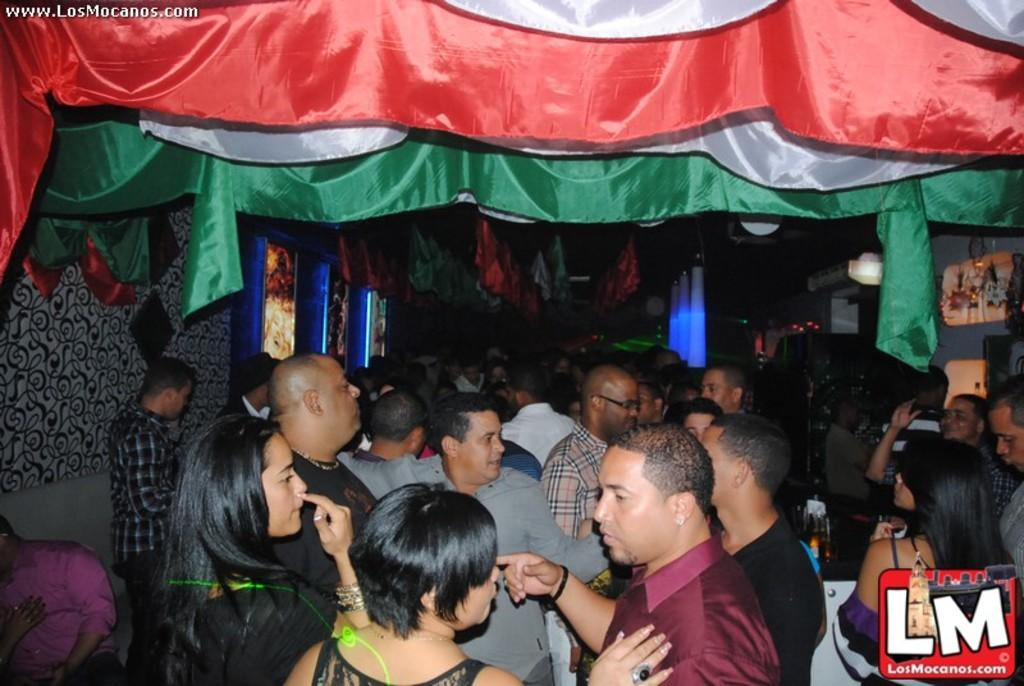What is the main subject of the image? The main subject of the image is a group of people standing. What can be seen in the background of the image? There are frames in the image. What type of clothing can be seen in the image? There are clothes of different colors in the image. What else is present in the image besides the people and frames? There are some objects in the image. Reasoning: Let's think step by step by following the guidelines step by step to produce the conversation. We start by identifying the main subject of the image, which is the group of people standing. Then, we describe the background and other elements present in the image, such as the frames, clothes, and objects. We ensure that each question can be answered definitively with the information given and avoid yes/no questions. Absurd Question/Answer: Where is the sink located in the image? There is no sink present in the image. What type of notebook is being used by the people in the image? There is no notebook present in the image. Where is the sink located in the image? There is no sink present in the image. What type of notebook is being used by the people in the image? There is no notebook present in the image. 